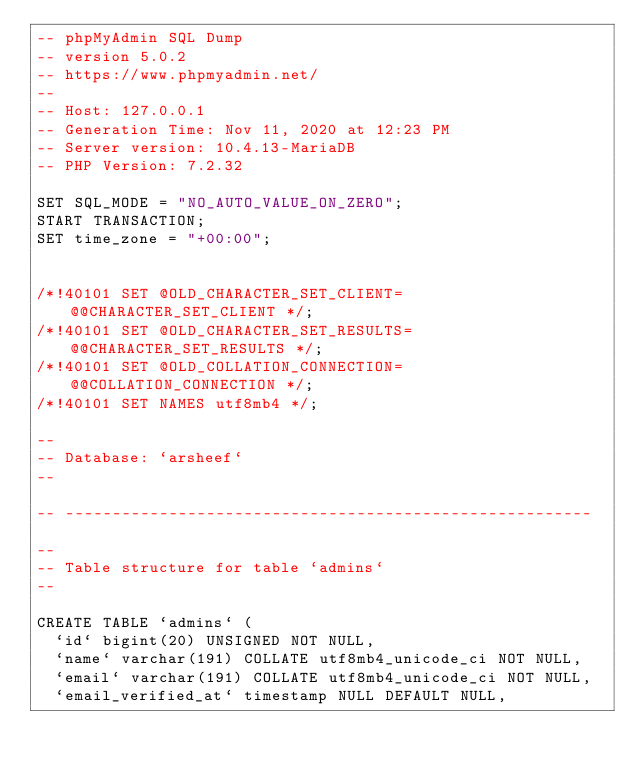Convert code to text. <code><loc_0><loc_0><loc_500><loc_500><_SQL_>-- phpMyAdmin SQL Dump
-- version 5.0.2
-- https://www.phpmyadmin.net/
--
-- Host: 127.0.0.1
-- Generation Time: Nov 11, 2020 at 12:23 PM
-- Server version: 10.4.13-MariaDB
-- PHP Version: 7.2.32

SET SQL_MODE = "NO_AUTO_VALUE_ON_ZERO";
START TRANSACTION;
SET time_zone = "+00:00";


/*!40101 SET @OLD_CHARACTER_SET_CLIENT=@@CHARACTER_SET_CLIENT */;
/*!40101 SET @OLD_CHARACTER_SET_RESULTS=@@CHARACTER_SET_RESULTS */;
/*!40101 SET @OLD_COLLATION_CONNECTION=@@COLLATION_CONNECTION */;
/*!40101 SET NAMES utf8mb4 */;

--
-- Database: `arsheef`
--

-- --------------------------------------------------------

--
-- Table structure for table `admins`
--

CREATE TABLE `admins` (
  `id` bigint(20) UNSIGNED NOT NULL,
  `name` varchar(191) COLLATE utf8mb4_unicode_ci NOT NULL,
  `email` varchar(191) COLLATE utf8mb4_unicode_ci NOT NULL,
  `email_verified_at` timestamp NULL DEFAULT NULL,</code> 